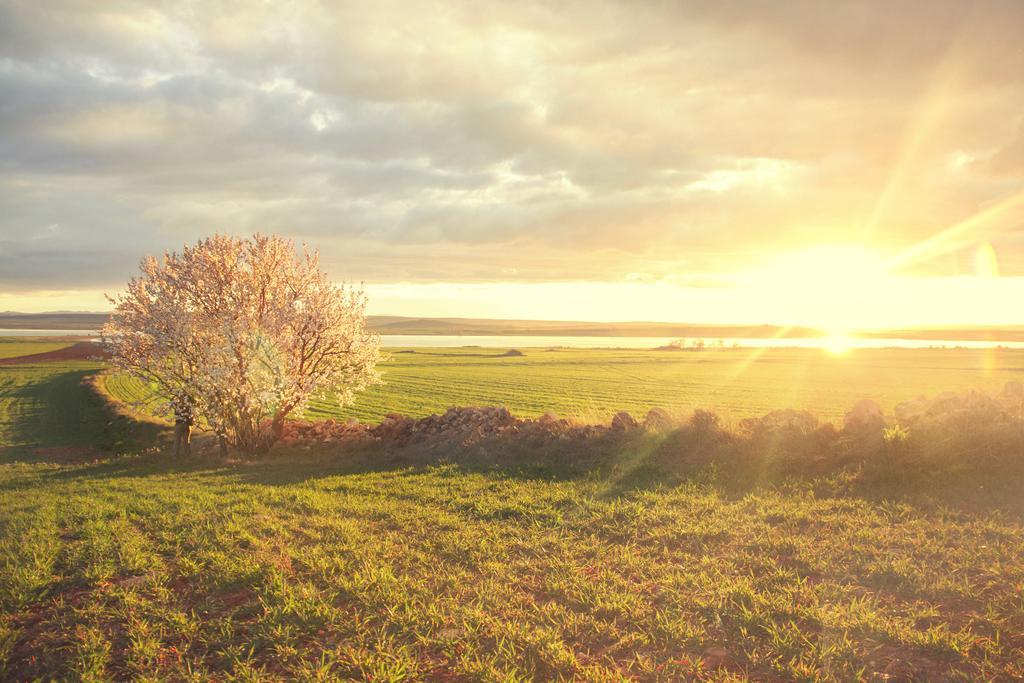Could you give a brief overview of what you see in this image? In this picture we can see some grass on the ground. There is a tree and some plants on the path. We can see sun rays in the sky. Sky is cloudy. 